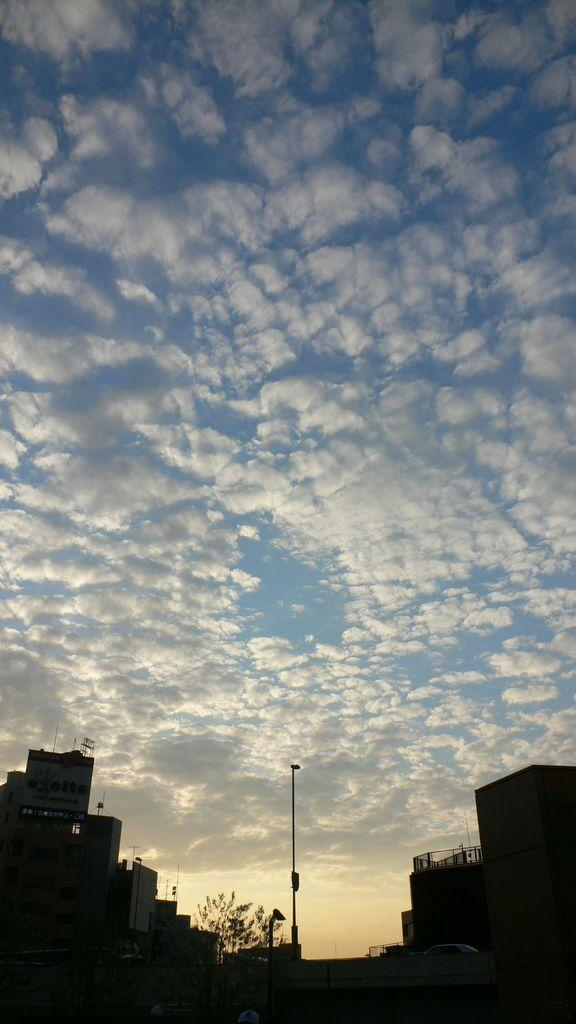What type of structures can be seen in the image? There are buildings in the image. What other natural elements are present in the image? There are trees in the image. What is located in the center of the image? There is a pole in the center of the image. What is visible at the top of the image? The sky is visible at the top of the image. What can be seen in the sky? There are clouds in the sky. Where is the cemetery located in the image? There is no cemetery present in the image. What type of cloud is the tent made of in the image? There is no tent present in the image, and clouds are not a material for making tents. 